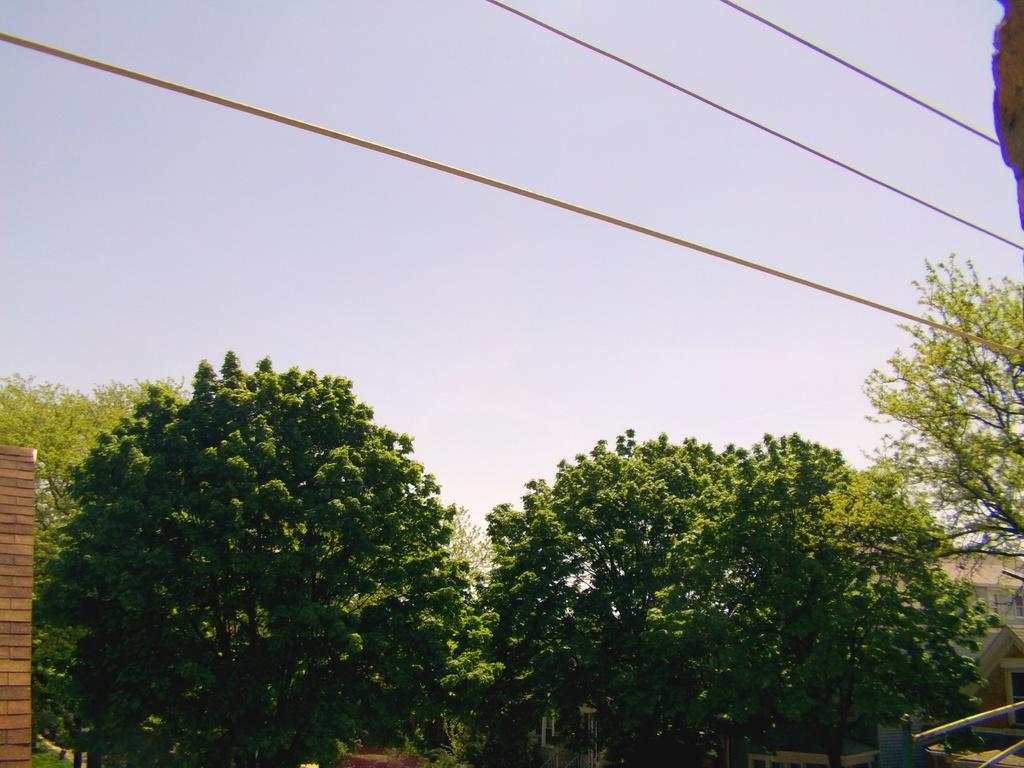What type of natural elements can be seen in the image? There are trees in the image. What man-made objects are present in the image? There are three wires in the image. What can be seen in the background of the image? There is a sky visible in the background of the image. What type of protest is taking place in the image? There is no protest present in the image; it only features trees, wires, and a sky. Can you tell me which doctor is responsible for the destruction in the image? There is no destruction or doctor present in the image; it only features trees, wires, and a sky. 